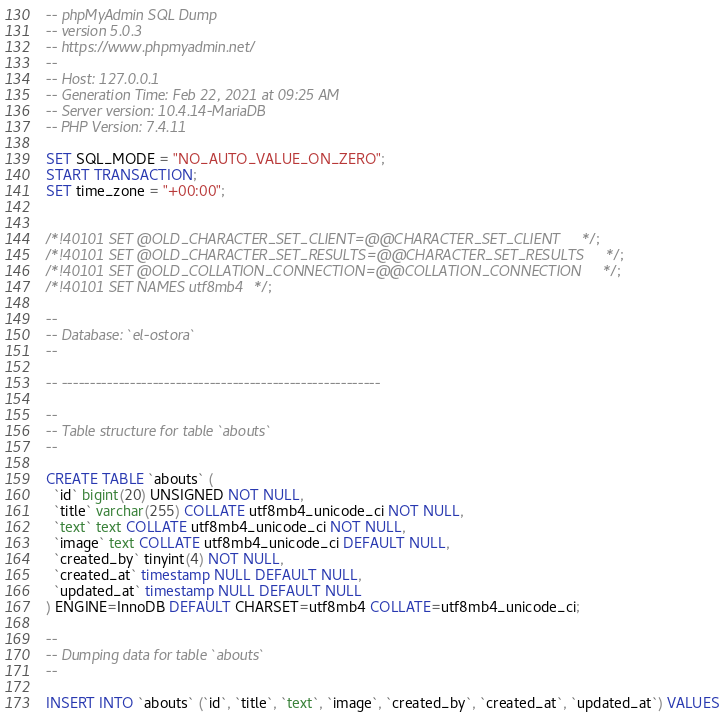<code> <loc_0><loc_0><loc_500><loc_500><_SQL_>-- phpMyAdmin SQL Dump
-- version 5.0.3
-- https://www.phpmyadmin.net/
--
-- Host: 127.0.0.1
-- Generation Time: Feb 22, 2021 at 09:25 AM
-- Server version: 10.4.14-MariaDB
-- PHP Version: 7.4.11

SET SQL_MODE = "NO_AUTO_VALUE_ON_ZERO";
START TRANSACTION;
SET time_zone = "+00:00";


/*!40101 SET @OLD_CHARACTER_SET_CLIENT=@@CHARACTER_SET_CLIENT */;
/*!40101 SET @OLD_CHARACTER_SET_RESULTS=@@CHARACTER_SET_RESULTS */;
/*!40101 SET @OLD_COLLATION_CONNECTION=@@COLLATION_CONNECTION */;
/*!40101 SET NAMES utf8mb4 */;

--
-- Database: `el-ostora`
--

-- --------------------------------------------------------

--
-- Table structure for table `abouts`
--

CREATE TABLE `abouts` (
  `id` bigint(20) UNSIGNED NOT NULL,
  `title` varchar(255) COLLATE utf8mb4_unicode_ci NOT NULL,
  `text` text COLLATE utf8mb4_unicode_ci NOT NULL,
  `image` text COLLATE utf8mb4_unicode_ci DEFAULT NULL,
  `created_by` tinyint(4) NOT NULL,
  `created_at` timestamp NULL DEFAULT NULL,
  `updated_at` timestamp NULL DEFAULT NULL
) ENGINE=InnoDB DEFAULT CHARSET=utf8mb4 COLLATE=utf8mb4_unicode_ci;

--
-- Dumping data for table `abouts`
--

INSERT INTO `abouts` (`id`, `title`, `text`, `image`, `created_by`, `created_at`, `updated_at`) VALUES</code> 